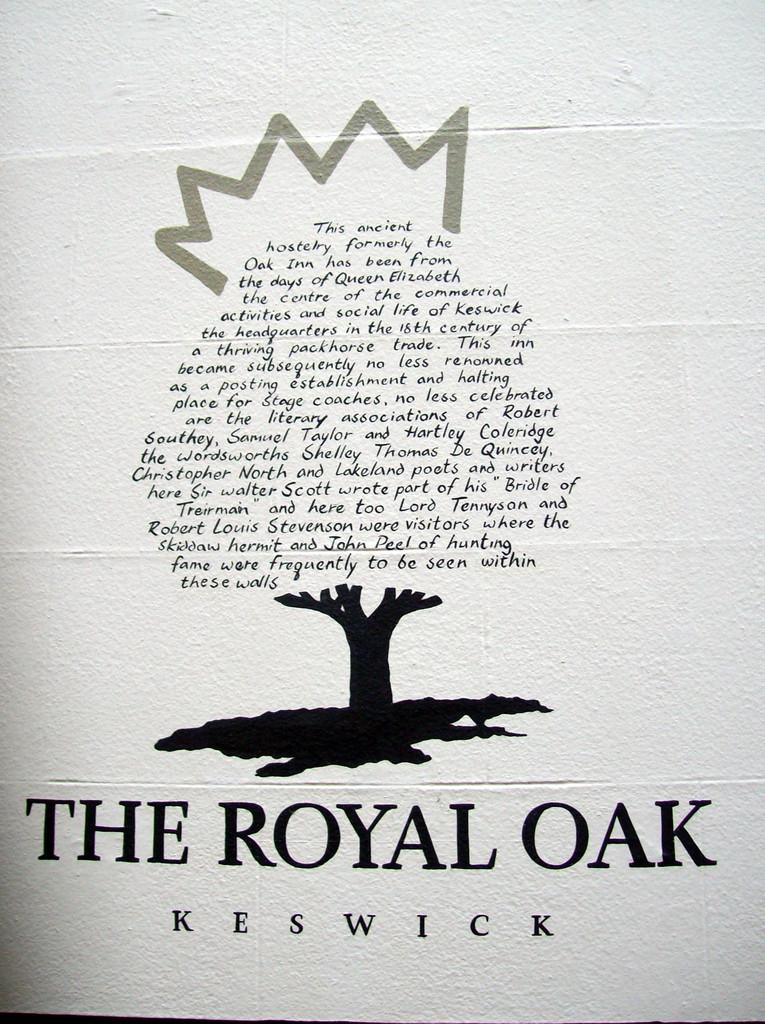What is the title of this book?
Keep it short and to the point. The royal oak. Who wrote this book?
Offer a very short reply. Keswick. 